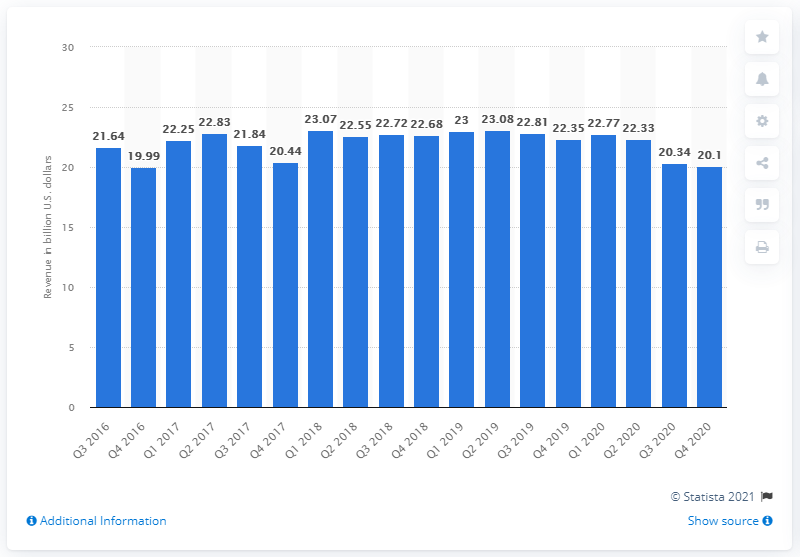Mention a couple of crucial points in this snapshot. The revenue of net interest expense for Bank of America in the fourth quarter of 2020 was 20.1. 